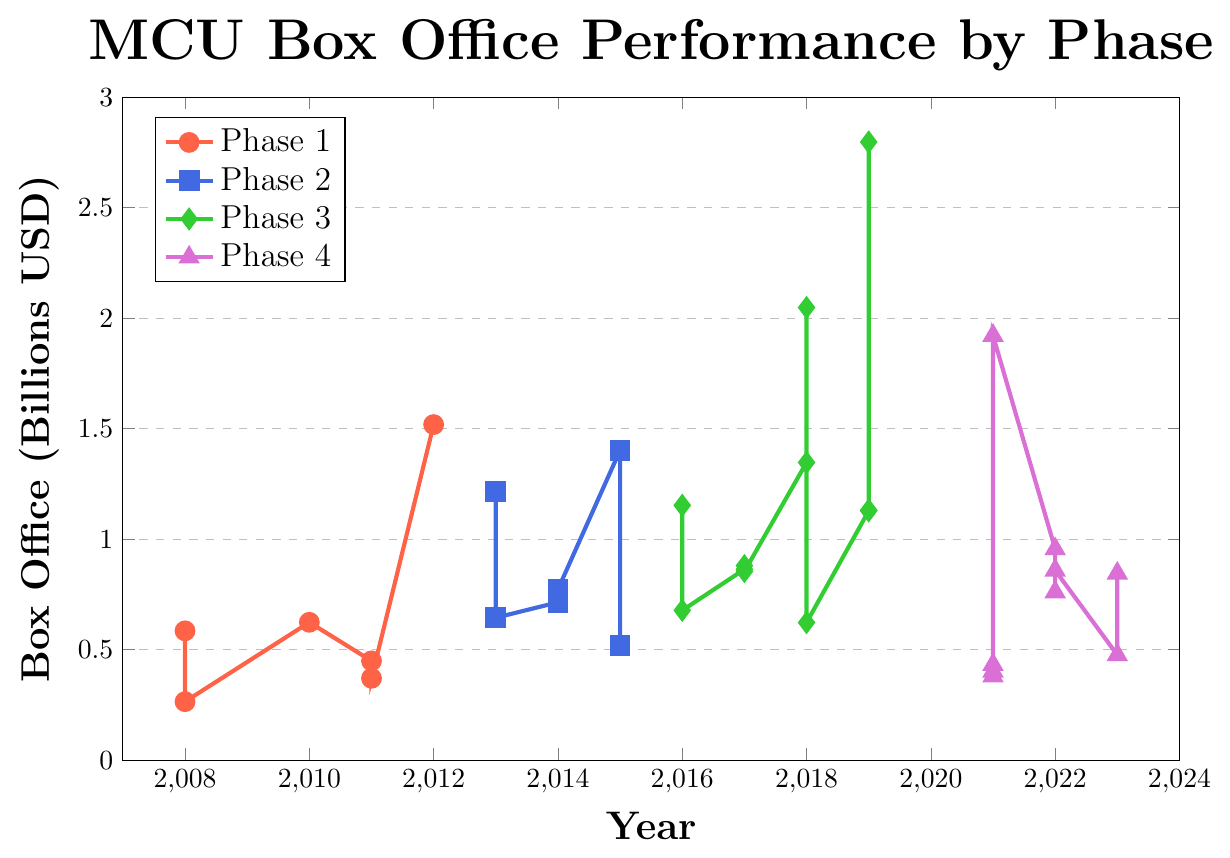What year hit the highest box office performance for the MCU? The year with the highest box office peak is identified by the maximum y-value on the chart. This peak is in 2019 during Phase 3, where the box office performance reaches approximately 2.8 billion USD (Avengers: Endgame).
Answer: 2019 Which MCU phase has the highest average box office performance? Calculate the average box office performance for each phase by summing the box office values within that phase and dividing by the number of films in that phase. Phase 3 has the highest average, as it contains several high-grossing films like Avengers: Infinity War and Avengers: Endgame.
Answer: Phase 3 Which film in Phase 4 had the highest box office? In Phase 4, look for the point with the highest y-value. The highest point in Phase 4 is in 2021, and it corresponds to Spider-Man: No Way Home with a box office performance of 1.9218 billion USD.
Answer: Spider-Man: No Way Home How did the box office performance change for Avengers films between phases? Compare the box office values of Avengers films across different phases. The Avengers (Phase 1) made 1.5188 billion, Avengers: Age of Ultron (Phase 2) made 1.4028 billion, Avengers: Infinity War (Phase 3) made 2.0484 billion, and Avengers: Endgame (Phase 3) made 2.7975 billion USD. The box office performance increased significantly from Phase 1 to Phase 3.
Answer: Increased What is the total box office performance for Phase 2? Sum the box office values of all films in Phase 2: 1.2148 + 0.6446 + 0.7144 + 0.7733 + 1.4028 + 0.5193 = 5.2692 billion USD.
Answer: 5.2692 billion USD Which phase shows the most significant drop in box office performance after a peak? Identify the phases and their peak box office values and compare subsequent values. In Phase 3, after Avengers: Endgame (2.7975 billion), there is a significant drop to Spider-Man: Far From Home (1.1319 billion USD).
Answer: Phase 3 For Phase 1 films, how many films grossed more than 500 million USD? Count the points in Phase 1 that have a y-value greater than 0.5 billion USD. These are Iron Man and Iron Man 2, each grossing more than 500 million USD.
Answer: 2 What phase had the most films grossing over 1 billion USD and which films were they? Identify the films in each phase that grossed over 1 billion USD. Phase 3 has the most: Captain America: Civil War, Black Panther, Avengers: Infinity War, Captain Marvel, Avengers: Endgame, and Spider-Man: Far From Home.
Answer: Phase 3 (6 films) Compare the box office performance of Thor films across phases. Identify the Thor films and compare their box office values:
- Thor (Phase 1): 0.4493 billion USD
- Thor: The Dark World (Phase 2): 0.6446 billion USD
- Thor: Ragnarok (Phase 3): 0.854 billion USD
- Thor: Love and Thunder (Phase 4): 0.7609 billion USD.
Thor: Ragnarok in Phase 3 had the highest performance.
Answer: Thor: Ragnarok 